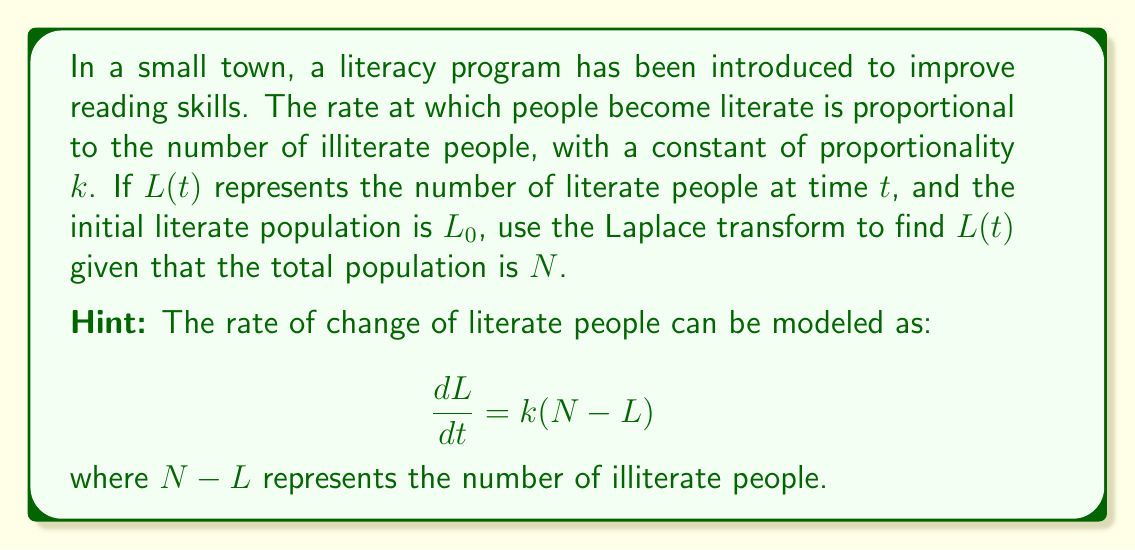Solve this math problem. Let's approach this step-by-step using the Laplace transform:

1) First, we set up our differential equation:

   $$\frac{dL}{dt} = k(N-L)$$

2) Apply the Laplace transform to both sides. Let $\mathcal{L}\{L(t)\} = \bar{L}(s)$:

   $$\mathcal{L}\{\frac{dL}{dt}\} = \mathcal{L}\{k(N-L)\}$$

3) Using Laplace transform properties:

   $$s\bar{L}(s) - L_0 = kN\frac{1}{s} - k\bar{L}(s)$$

4) Rearrange the equation:

   $$s\bar{L}(s) + k\bar{L}(s) = L_0 + \frac{kN}{s}$$

   $$(s+k)\bar{L}(s) = L_0 + \frac{kN}{s}$$

5) Solve for $\bar{L}(s)$:

   $$\bar{L}(s) = \frac{L_0}{s+k} + \frac{kN}{s(s+k)}$$

6) This can be rewritten as:

   $$\bar{L}(s) = \frac{L_0}{s+k} + \frac{N}{s} - \frac{N}{s+k}$$

7) Now, we can use inverse Laplace transforms:

   $$L(t) = L_0e^{-kt} + N - Ne^{-kt}$$

8) Simplify:

   $$L(t) = N - (N-L_0)e^{-kt}$$

This is our final solution for $L(t)$.
Answer: $$L(t) = N - (N-L_0)e^{-kt}$$ 